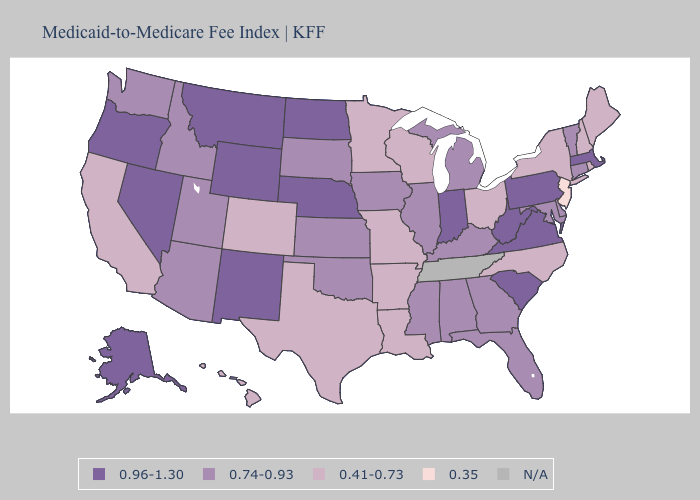Which states hav the highest value in the South?
Keep it brief. South Carolina, Virginia, West Virginia. Name the states that have a value in the range 0.96-1.30?
Answer briefly. Alaska, Indiana, Massachusetts, Montana, Nebraska, Nevada, New Mexico, North Dakota, Oregon, Pennsylvania, South Carolina, Virginia, West Virginia, Wyoming. What is the lowest value in the USA?
Give a very brief answer. 0.35. How many symbols are there in the legend?
Be succinct. 5. What is the value of Connecticut?
Concise answer only. 0.74-0.93. Name the states that have a value in the range N/A?
Keep it brief. Tennessee. Name the states that have a value in the range 0.96-1.30?
Be succinct. Alaska, Indiana, Massachusetts, Montana, Nebraska, Nevada, New Mexico, North Dakota, Oregon, Pennsylvania, South Carolina, Virginia, West Virginia, Wyoming. Name the states that have a value in the range 0.96-1.30?
Write a very short answer. Alaska, Indiana, Massachusetts, Montana, Nebraska, Nevada, New Mexico, North Dakota, Oregon, Pennsylvania, South Carolina, Virginia, West Virginia, Wyoming. Name the states that have a value in the range 0.41-0.73?
Answer briefly. Arkansas, California, Colorado, Hawaii, Louisiana, Maine, Minnesota, Missouri, New Hampshire, New York, North Carolina, Ohio, Rhode Island, Texas, Wisconsin. Does New Jersey have the lowest value in the USA?
Give a very brief answer. Yes. Which states have the highest value in the USA?
Be succinct. Alaska, Indiana, Massachusetts, Montana, Nebraska, Nevada, New Mexico, North Dakota, Oregon, Pennsylvania, South Carolina, Virginia, West Virginia, Wyoming. What is the value of Tennessee?
Answer briefly. N/A. 